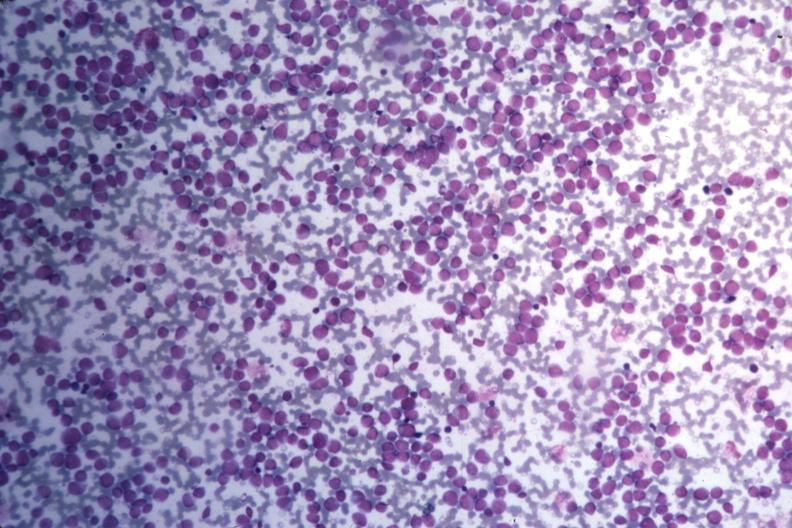what is present?
Answer the question using a single word or phrase. Bone marrow 